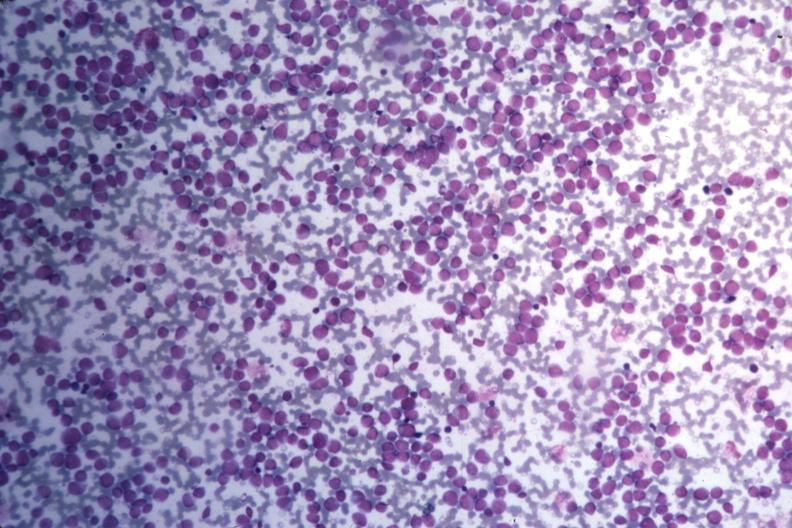what is present?
Answer the question using a single word or phrase. Bone marrow 